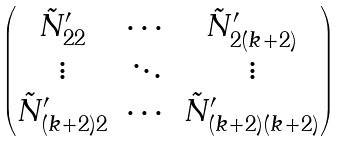Convert formula to latex. <formula><loc_0><loc_0><loc_500><loc_500>\begin{pmatrix} \tilde { N } _ { 2 2 } ^ { \prime } & \cdots & \tilde { N } _ { 2 ( k + 2 ) } ^ { \prime } \\ \vdots & \ddots & \vdots \\ \tilde { N } _ { ( k + 2 ) 2 } ^ { \prime } & \cdots & \tilde { N } _ { ( k + 2 ) ( k + 2 ) } ^ { \prime } \end{pmatrix}</formula> 